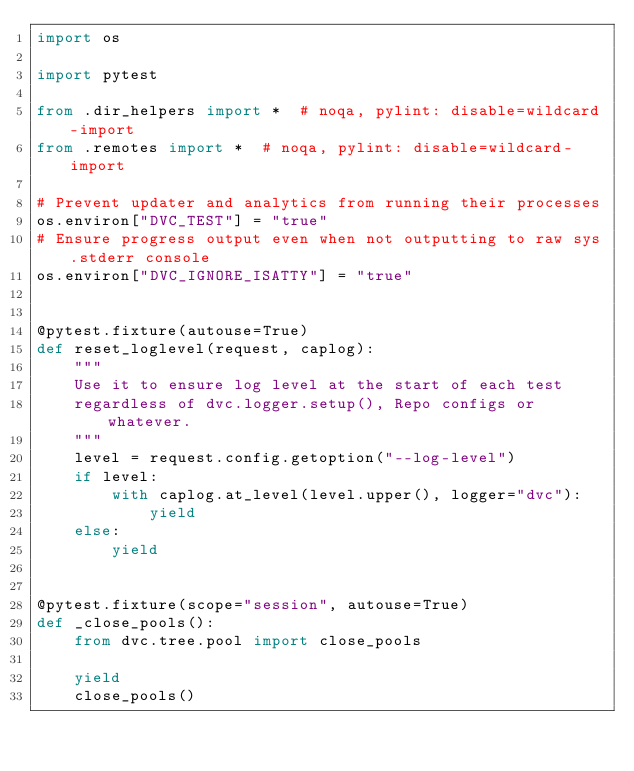Convert code to text. <code><loc_0><loc_0><loc_500><loc_500><_Python_>import os

import pytest

from .dir_helpers import *  # noqa, pylint: disable=wildcard-import
from .remotes import *  # noqa, pylint: disable=wildcard-import

# Prevent updater and analytics from running their processes
os.environ["DVC_TEST"] = "true"
# Ensure progress output even when not outputting to raw sys.stderr console
os.environ["DVC_IGNORE_ISATTY"] = "true"


@pytest.fixture(autouse=True)
def reset_loglevel(request, caplog):
    """
    Use it to ensure log level at the start of each test
    regardless of dvc.logger.setup(), Repo configs or whatever.
    """
    level = request.config.getoption("--log-level")
    if level:
        with caplog.at_level(level.upper(), logger="dvc"):
            yield
    else:
        yield


@pytest.fixture(scope="session", autouse=True)
def _close_pools():
    from dvc.tree.pool import close_pools

    yield
    close_pools()
</code> 